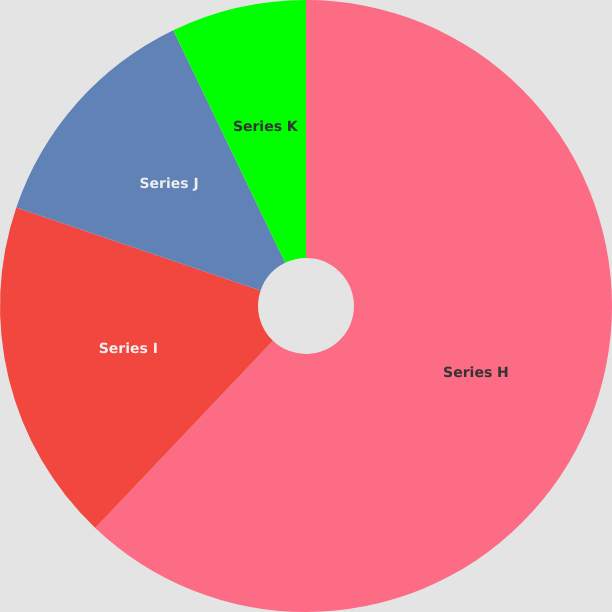Convert chart to OTSL. <chart><loc_0><loc_0><loc_500><loc_500><pie_chart><fcel>Series H<fcel>Series I<fcel>Series J<fcel>Series K<nl><fcel>62.09%<fcel>18.13%<fcel>12.64%<fcel>7.14%<nl></chart> 